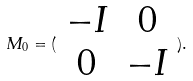<formula> <loc_0><loc_0><loc_500><loc_500>M _ { 0 } = ( \begin{array} { c c } - I & 0 \\ 0 & - I \end{array} ) .</formula> 